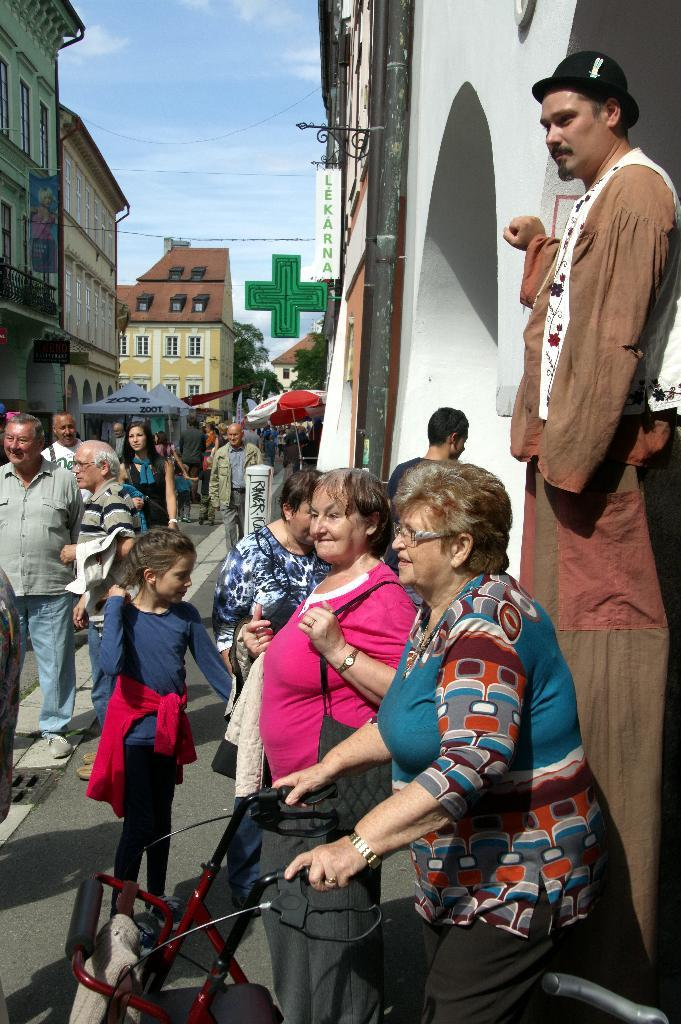What is the woman in the image doing? The woman is on a cycle in the image. What can be seen in the foreground of the image? There are people standing on a path in the image. What is visible in the background of the image? There are buildings and the sky in the background of the image. What song is the woman singing while riding the cycle in the image? There is no indication in the image that the woman is singing a song, so it cannot be determined from the picture. 